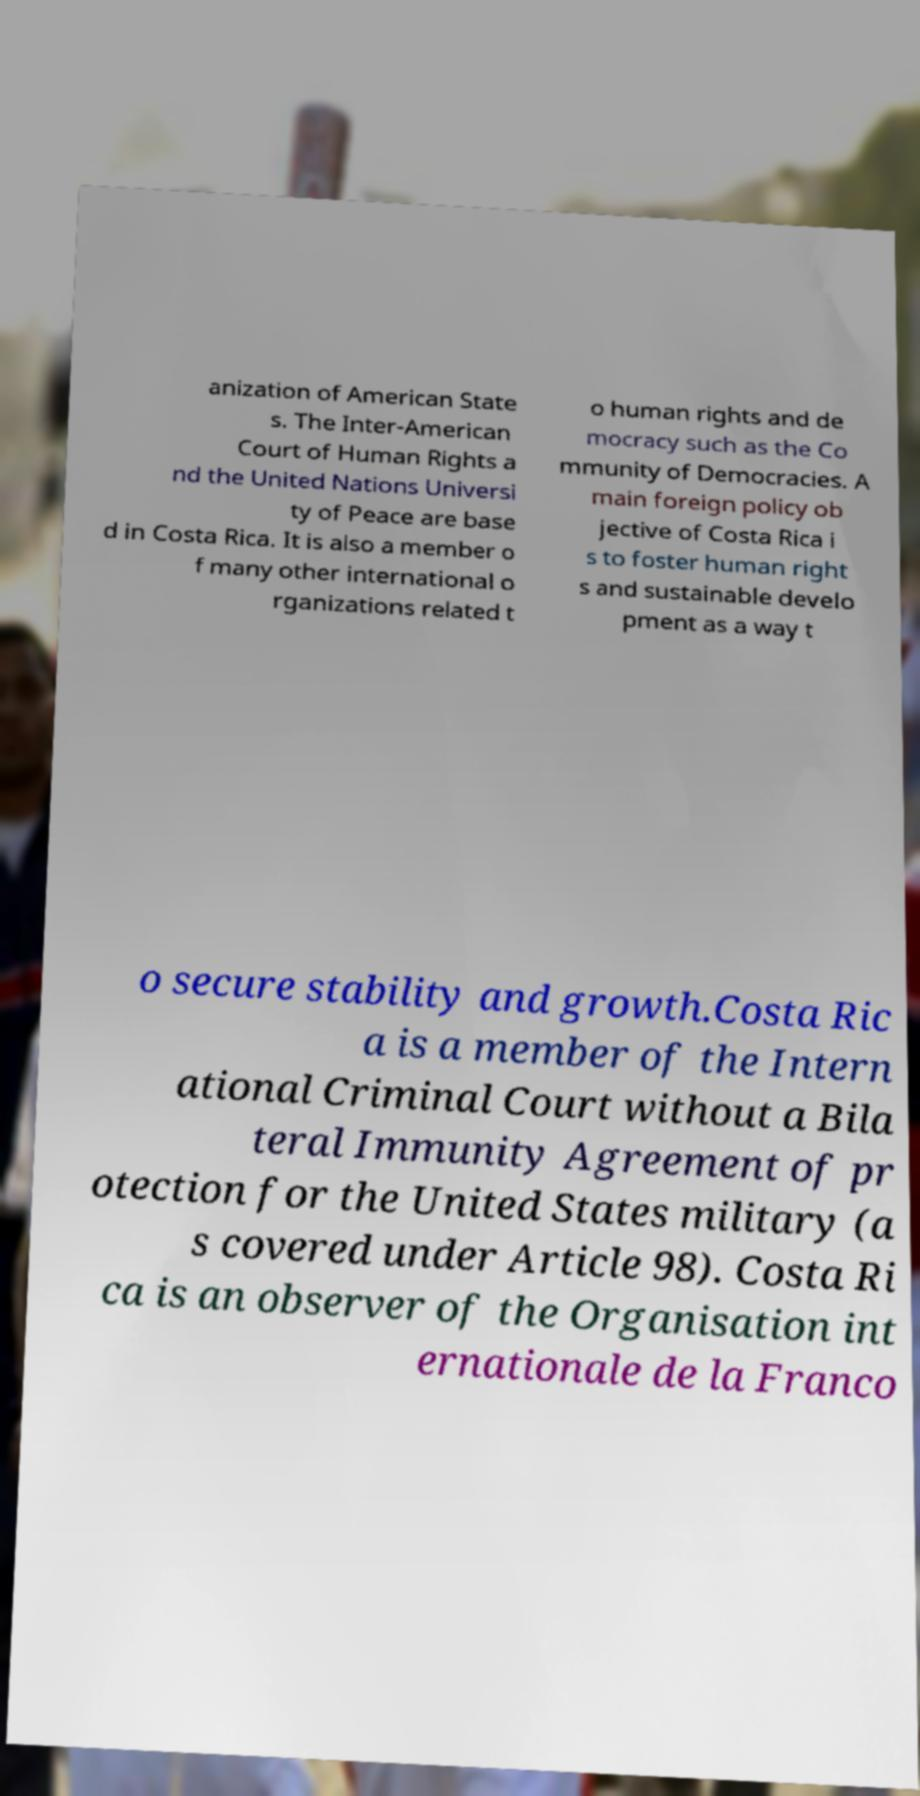I need the written content from this picture converted into text. Can you do that? anization of American State s. The Inter-American Court of Human Rights a nd the United Nations Universi ty of Peace are base d in Costa Rica. It is also a member o f many other international o rganizations related t o human rights and de mocracy such as the Co mmunity of Democracies. A main foreign policy ob jective of Costa Rica i s to foster human right s and sustainable develo pment as a way t o secure stability and growth.Costa Ric a is a member of the Intern ational Criminal Court without a Bila teral Immunity Agreement of pr otection for the United States military (a s covered under Article 98). Costa Ri ca is an observer of the Organisation int ernationale de la Franco 